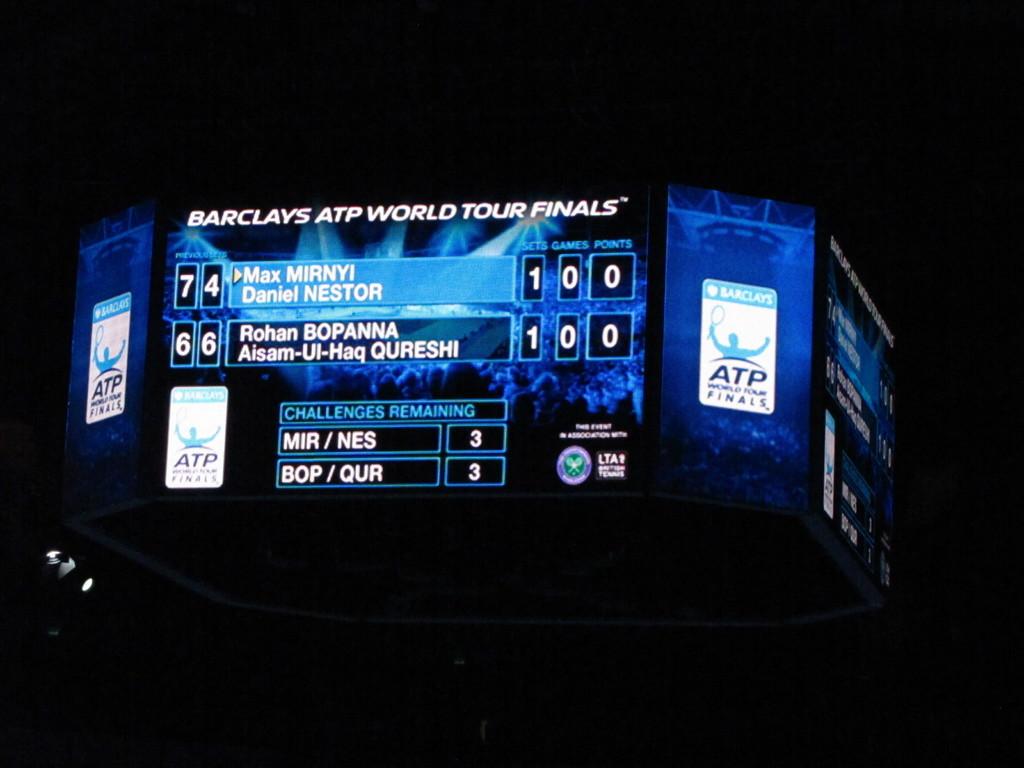Who is the sponsor of these world tour finals?
Your answer should be very brief. Barclays. What sport are they talking about?
Offer a very short reply. Tennis. 